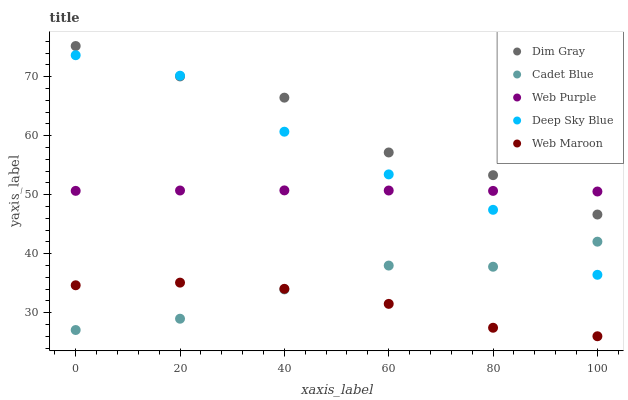Does Web Maroon have the minimum area under the curve?
Answer yes or no. Yes. Does Dim Gray have the maximum area under the curve?
Answer yes or no. Yes. Does Web Purple have the minimum area under the curve?
Answer yes or no. No. Does Web Purple have the maximum area under the curve?
Answer yes or no. No. Is Web Purple the smoothest?
Answer yes or no. Yes. Is Dim Gray the roughest?
Answer yes or no. Yes. Is Dim Gray the smoothest?
Answer yes or no. No. Is Web Purple the roughest?
Answer yes or no. No. Does Web Maroon have the lowest value?
Answer yes or no. Yes. Does Dim Gray have the lowest value?
Answer yes or no. No. Does Dim Gray have the highest value?
Answer yes or no. Yes. Does Web Purple have the highest value?
Answer yes or no. No. Is Cadet Blue less than Web Purple?
Answer yes or no. Yes. Is Dim Gray greater than Web Maroon?
Answer yes or no. Yes. Does Cadet Blue intersect Deep Sky Blue?
Answer yes or no. Yes. Is Cadet Blue less than Deep Sky Blue?
Answer yes or no. No. Is Cadet Blue greater than Deep Sky Blue?
Answer yes or no. No. Does Cadet Blue intersect Web Purple?
Answer yes or no. No. 